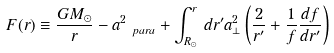Convert formula to latex. <formula><loc_0><loc_0><loc_500><loc_500>F ( r ) \equiv \frac { G M _ { \odot } } { r } - a _ { \ p a r a } ^ { 2 } + \int _ { R _ { \odot } } ^ { r } \, d r ^ { \prime } a _ { \perp } ^ { 2 } \left ( \frac { 2 } { r ^ { \prime } } + \frac { 1 } { f } \frac { d f } { d r ^ { \prime } } \right )</formula> 